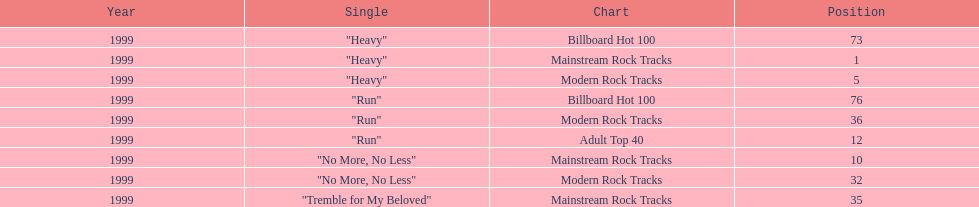What number of singles from "dosage" showed up on the modern rock tracks charts? 3. 